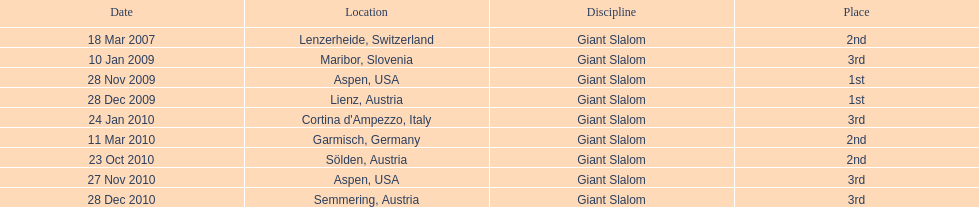What was the final position of the last race in december 2010? 3rd. Can you parse all the data within this table? {'header': ['Date', 'Location', 'Discipline', 'Place'], 'rows': [['18 Mar 2007', 'Lenzerheide, Switzerland', 'Giant Slalom', '2nd'], ['10 Jan 2009', 'Maribor, Slovenia', 'Giant Slalom', '3rd'], ['28 Nov 2009', 'Aspen, USA', 'Giant Slalom', '1st'], ['28 Dec 2009', 'Lienz, Austria', 'Giant Slalom', '1st'], ['24 Jan 2010', "Cortina d'Ampezzo, Italy", 'Giant Slalom', '3rd'], ['11 Mar 2010', 'Garmisch, Germany', 'Giant Slalom', '2nd'], ['23 Oct 2010', 'Sölden, Austria', 'Giant Slalom', '2nd'], ['27 Nov 2010', 'Aspen, USA', 'Giant Slalom', '3rd'], ['28 Dec 2010', 'Semmering, Austria', 'Giant Slalom', '3rd']]} 